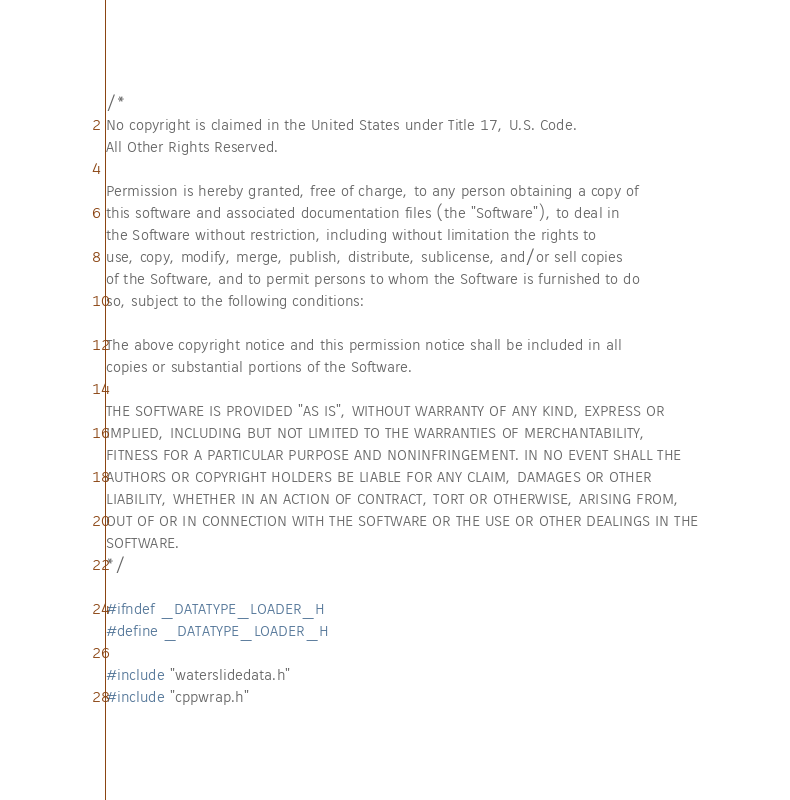Convert code to text. <code><loc_0><loc_0><loc_500><loc_500><_C_>/*
No copyright is claimed in the United States under Title 17, U.S. Code.
All Other Rights Reserved.

Permission is hereby granted, free of charge, to any person obtaining a copy of
this software and associated documentation files (the "Software"), to deal in
the Software without restriction, including without limitation the rights to
use, copy, modify, merge, publish, distribute, sublicense, and/or sell copies
of the Software, and to permit persons to whom the Software is furnished to do
so, subject to the following conditions:

The above copyright notice and this permission notice shall be included in all
copies or substantial portions of the Software.

THE SOFTWARE IS PROVIDED "AS IS", WITHOUT WARRANTY OF ANY KIND, EXPRESS OR
IMPLIED, INCLUDING BUT NOT LIMITED TO THE WARRANTIES OF MERCHANTABILITY,
FITNESS FOR A PARTICULAR PURPOSE AND NONINFRINGEMENT. IN NO EVENT SHALL THE
AUTHORS OR COPYRIGHT HOLDERS BE LIABLE FOR ANY CLAIM, DAMAGES OR OTHER
LIABILITY, WHETHER IN AN ACTION OF CONTRACT, TORT OR OTHERWISE, ARISING FROM,
OUT OF OR IN CONNECTION WITH THE SOFTWARE OR THE USE OR OTHER DEALINGS IN THE
SOFTWARE.
*/

#ifndef _DATATYPE_LOADER_H
#define _DATATYPE_LOADER_H

#include "waterslidedata.h"
#include "cppwrap.h"
</code> 